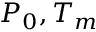<formula> <loc_0><loc_0><loc_500><loc_500>P _ { 0 } , T _ { m }</formula> 